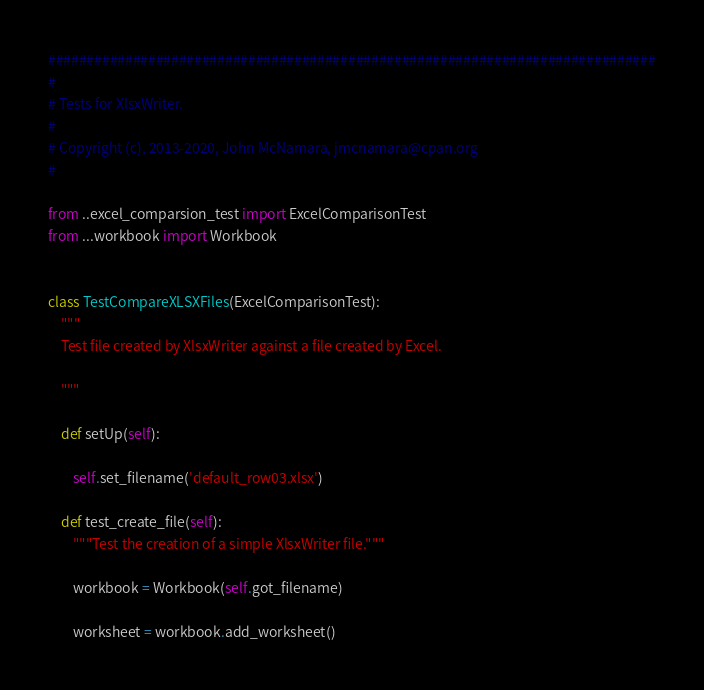<code> <loc_0><loc_0><loc_500><loc_500><_Python_>###############################################################################
#
# Tests for XlsxWriter.
#
# Copyright (c), 2013-2020, John McNamara, jmcnamara@cpan.org
#

from ..excel_comparsion_test import ExcelComparisonTest
from ...workbook import Workbook


class TestCompareXLSXFiles(ExcelComparisonTest):
    """
    Test file created by XlsxWriter against a file created by Excel.

    """

    def setUp(self):

        self.set_filename('default_row03.xlsx')

    def test_create_file(self):
        """Test the creation of a simple XlsxWriter file."""

        workbook = Workbook(self.got_filename)

        worksheet = workbook.add_worksheet()
</code> 